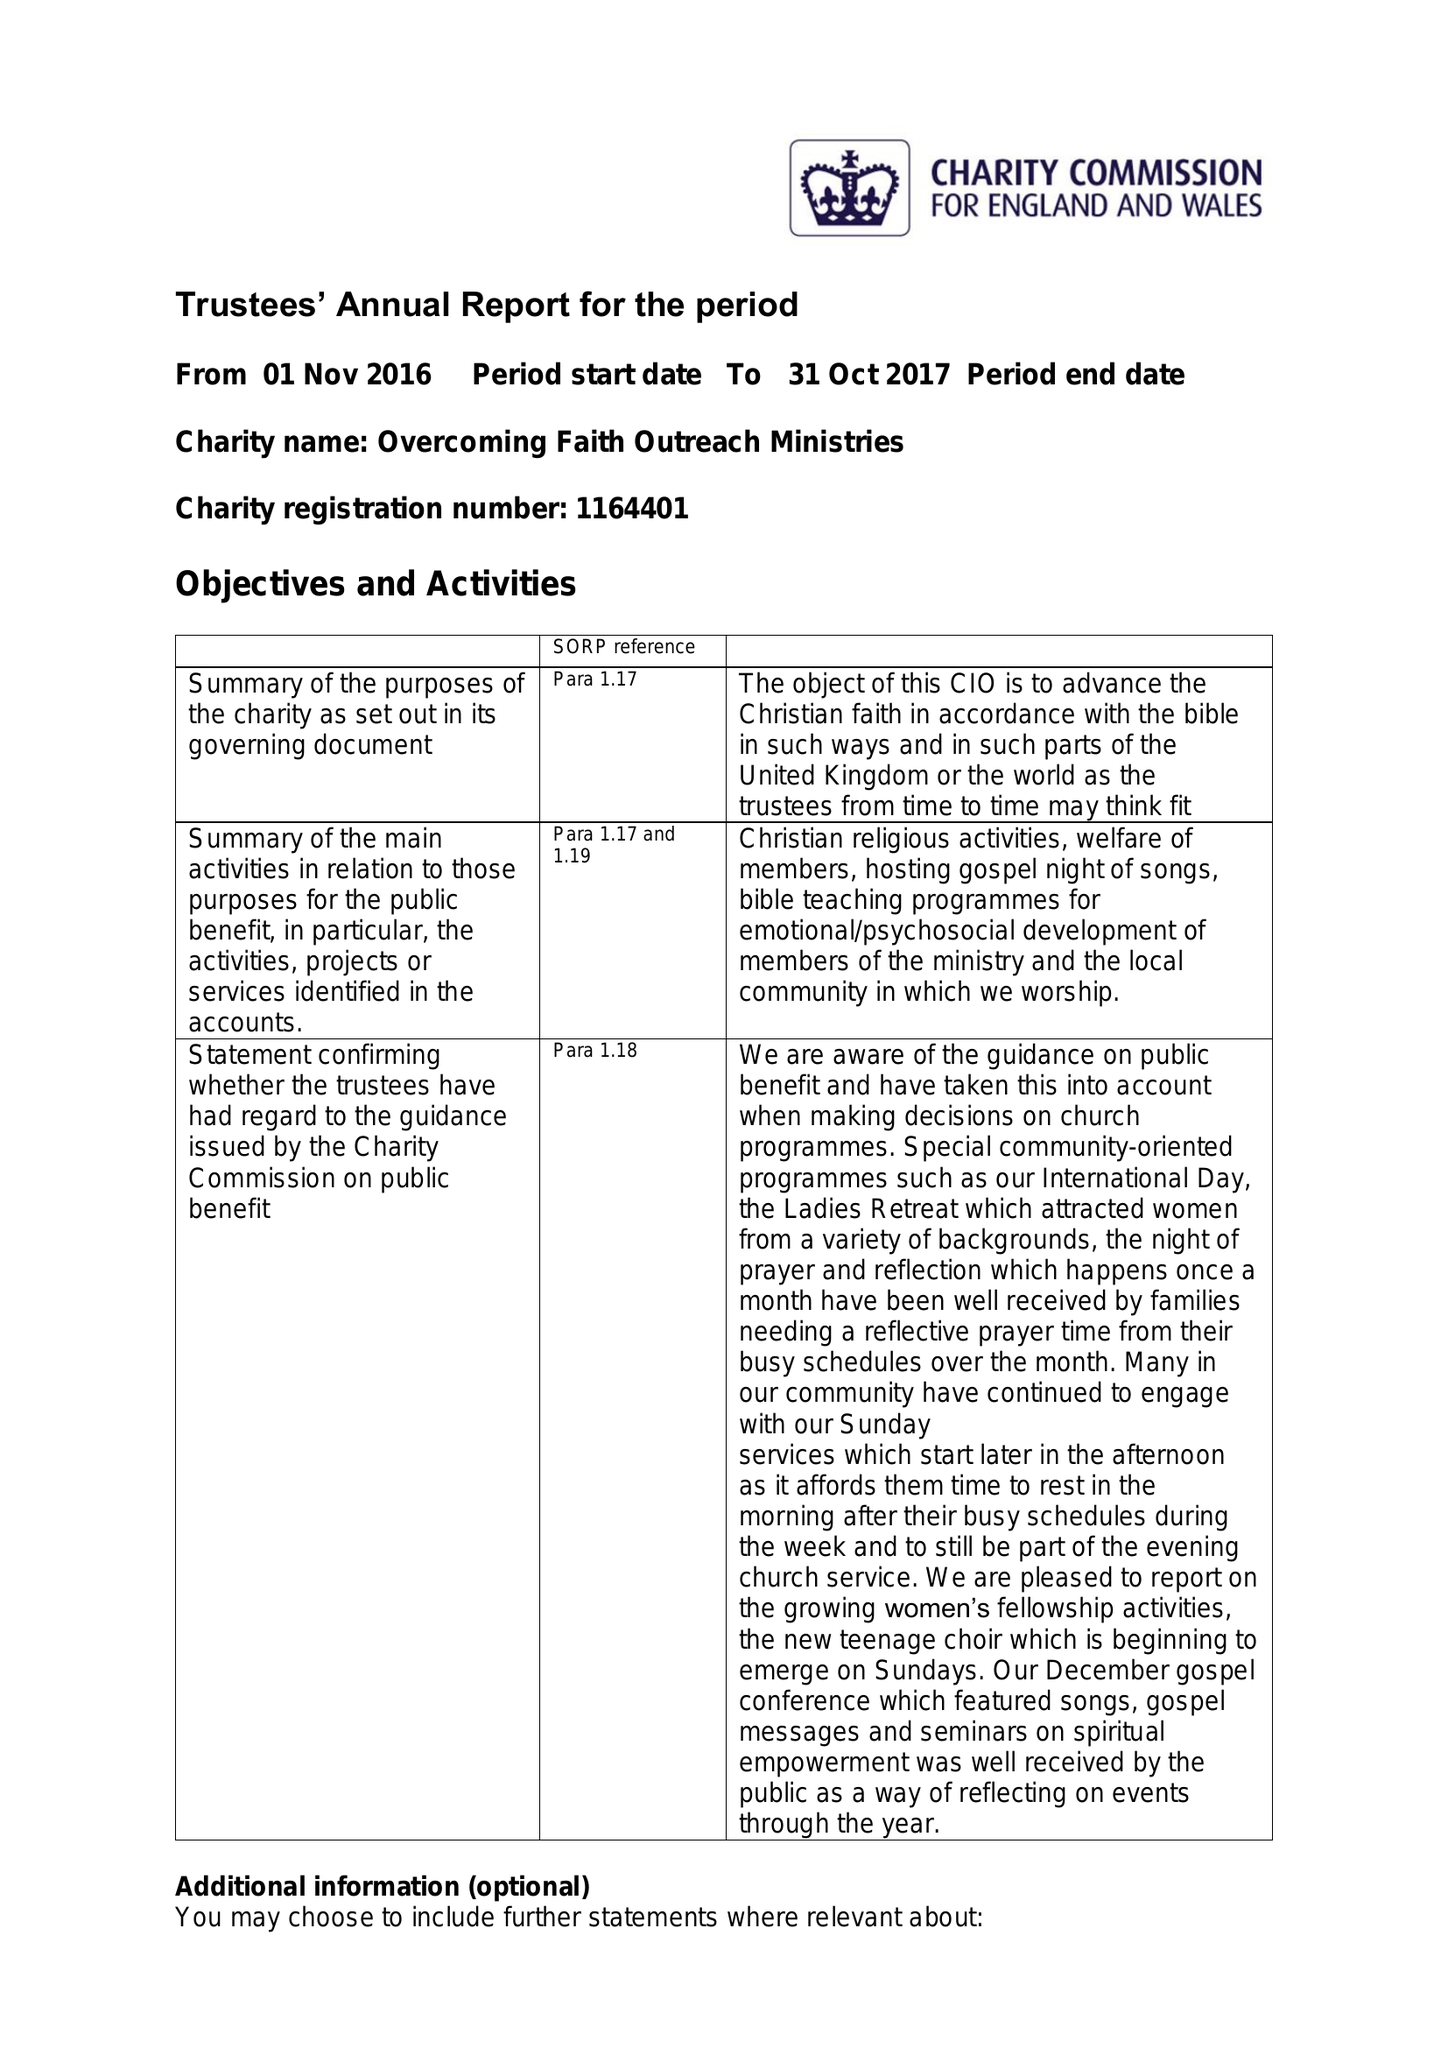What is the value for the income_annually_in_british_pounds?
Answer the question using a single word or phrase. 16176.00 